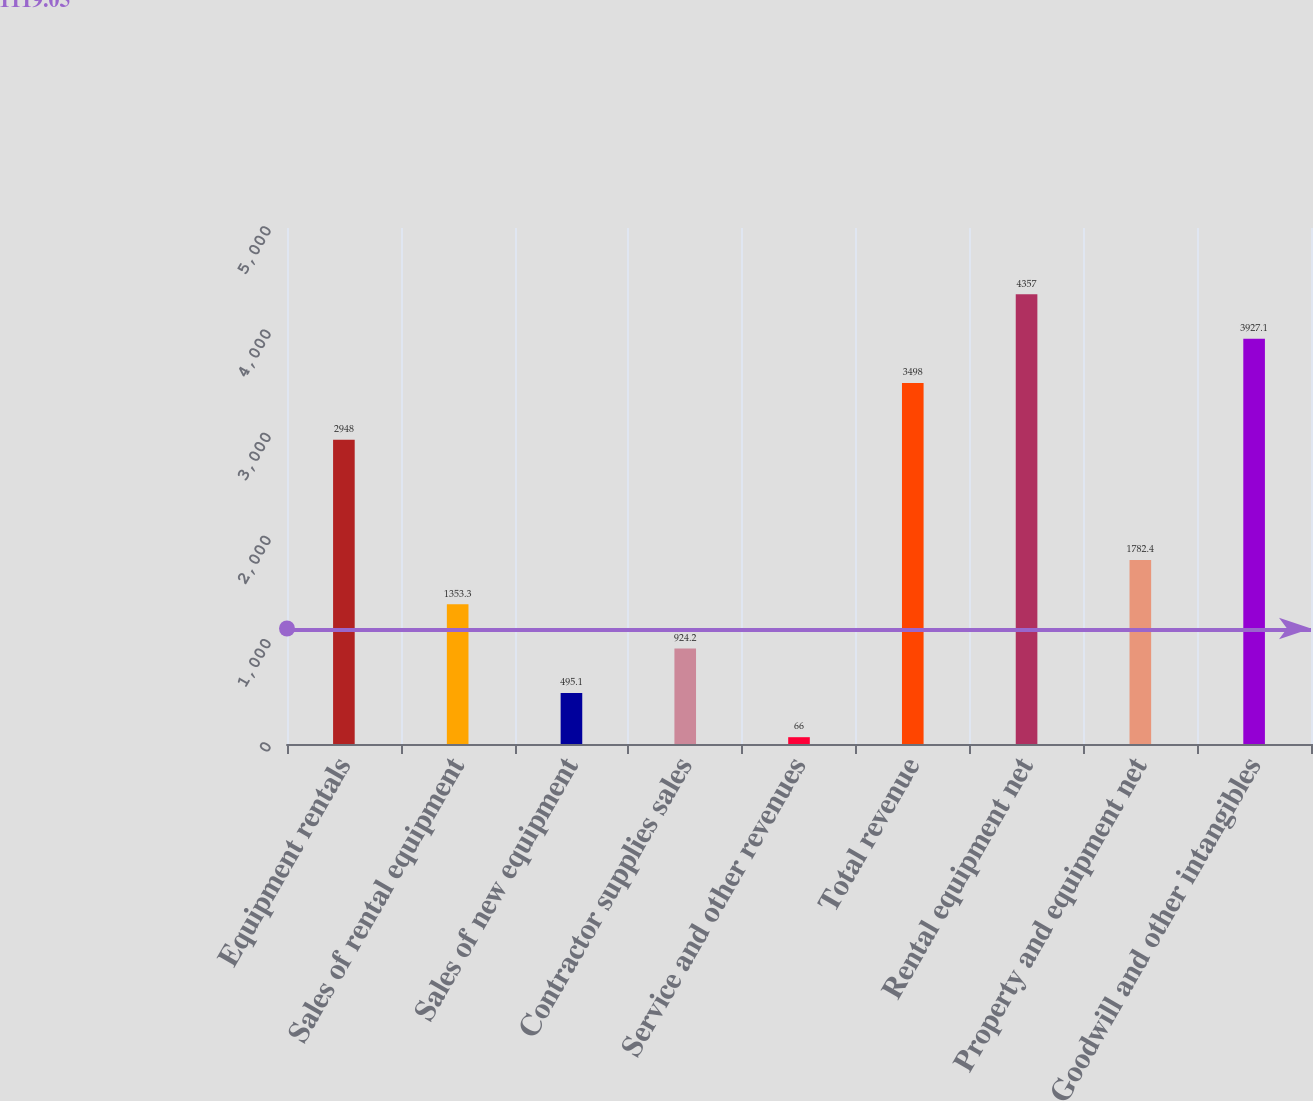<chart> <loc_0><loc_0><loc_500><loc_500><bar_chart><fcel>Equipment rentals<fcel>Sales of rental equipment<fcel>Sales of new equipment<fcel>Contractor supplies sales<fcel>Service and other revenues<fcel>Total revenue<fcel>Rental equipment net<fcel>Property and equipment net<fcel>Goodwill and other intangibles<nl><fcel>2948<fcel>1353.3<fcel>495.1<fcel>924.2<fcel>66<fcel>3498<fcel>4357<fcel>1782.4<fcel>3927.1<nl></chart> 